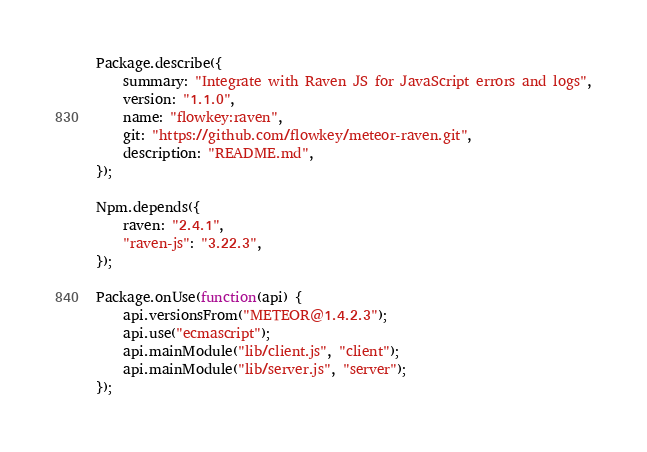<code> <loc_0><loc_0><loc_500><loc_500><_JavaScript_>Package.describe({
    summary: "Integrate with Raven JS for JavaScript errors and logs",
    version: "1.1.0",
    name: "flowkey:raven",
    git: "https://github.com/flowkey/meteor-raven.git",
    description: "README.md",
});

Npm.depends({
    raven: "2.4.1",
    "raven-js": "3.22.3",
});

Package.onUse(function(api) {
    api.versionsFrom("METEOR@1.4.2.3");
    api.use("ecmascript");
    api.mainModule("lib/client.js", "client");
    api.mainModule("lib/server.js", "server");
});
</code> 